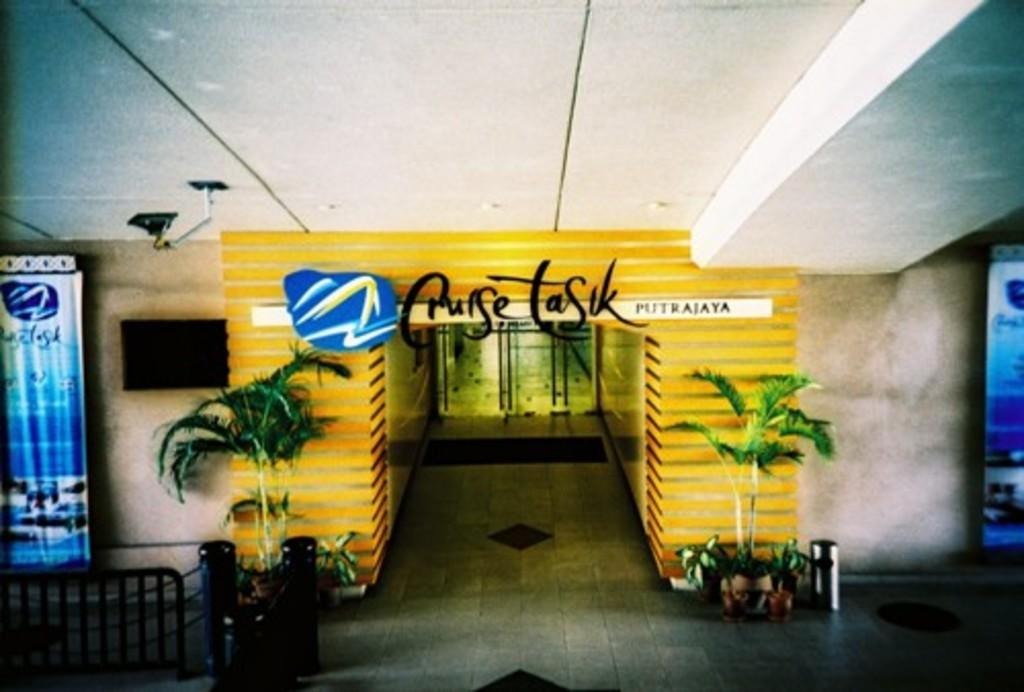Where do the doors lead to?
Provide a succinct answer. Cruise tasik. What word on the far right in smaller writing?
Offer a terse response. Putrajaya. 